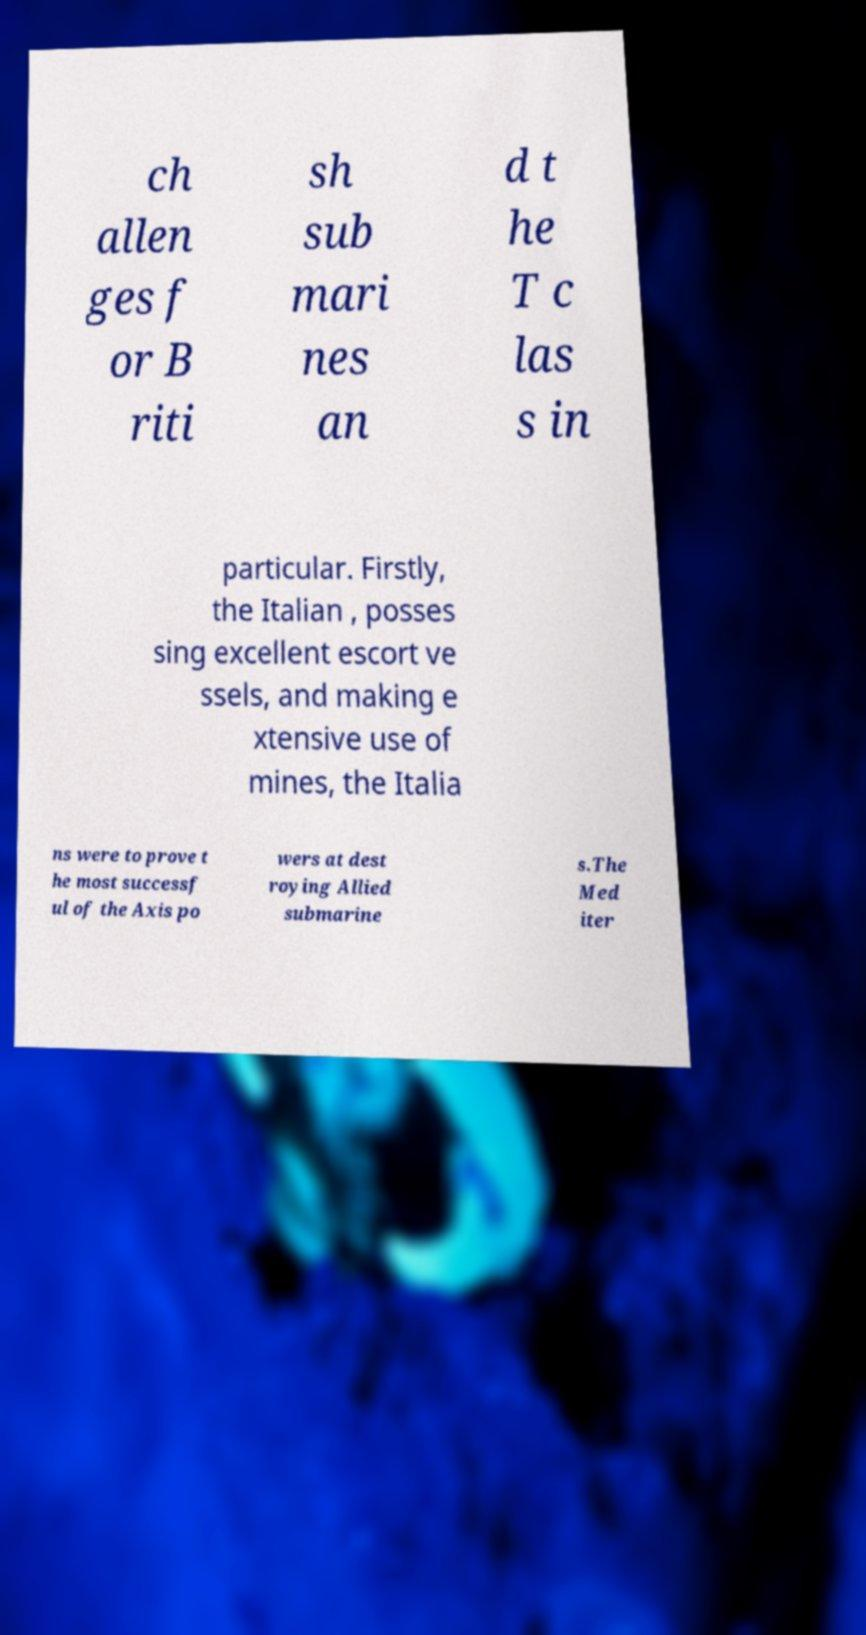Can you read and provide the text displayed in the image?This photo seems to have some interesting text. Can you extract and type it out for me? ch allen ges f or B riti sh sub mari nes an d t he T c las s in particular. Firstly, the Italian , posses sing excellent escort ve ssels, and making e xtensive use of mines, the Italia ns were to prove t he most successf ul of the Axis po wers at dest roying Allied submarine s.The Med iter 